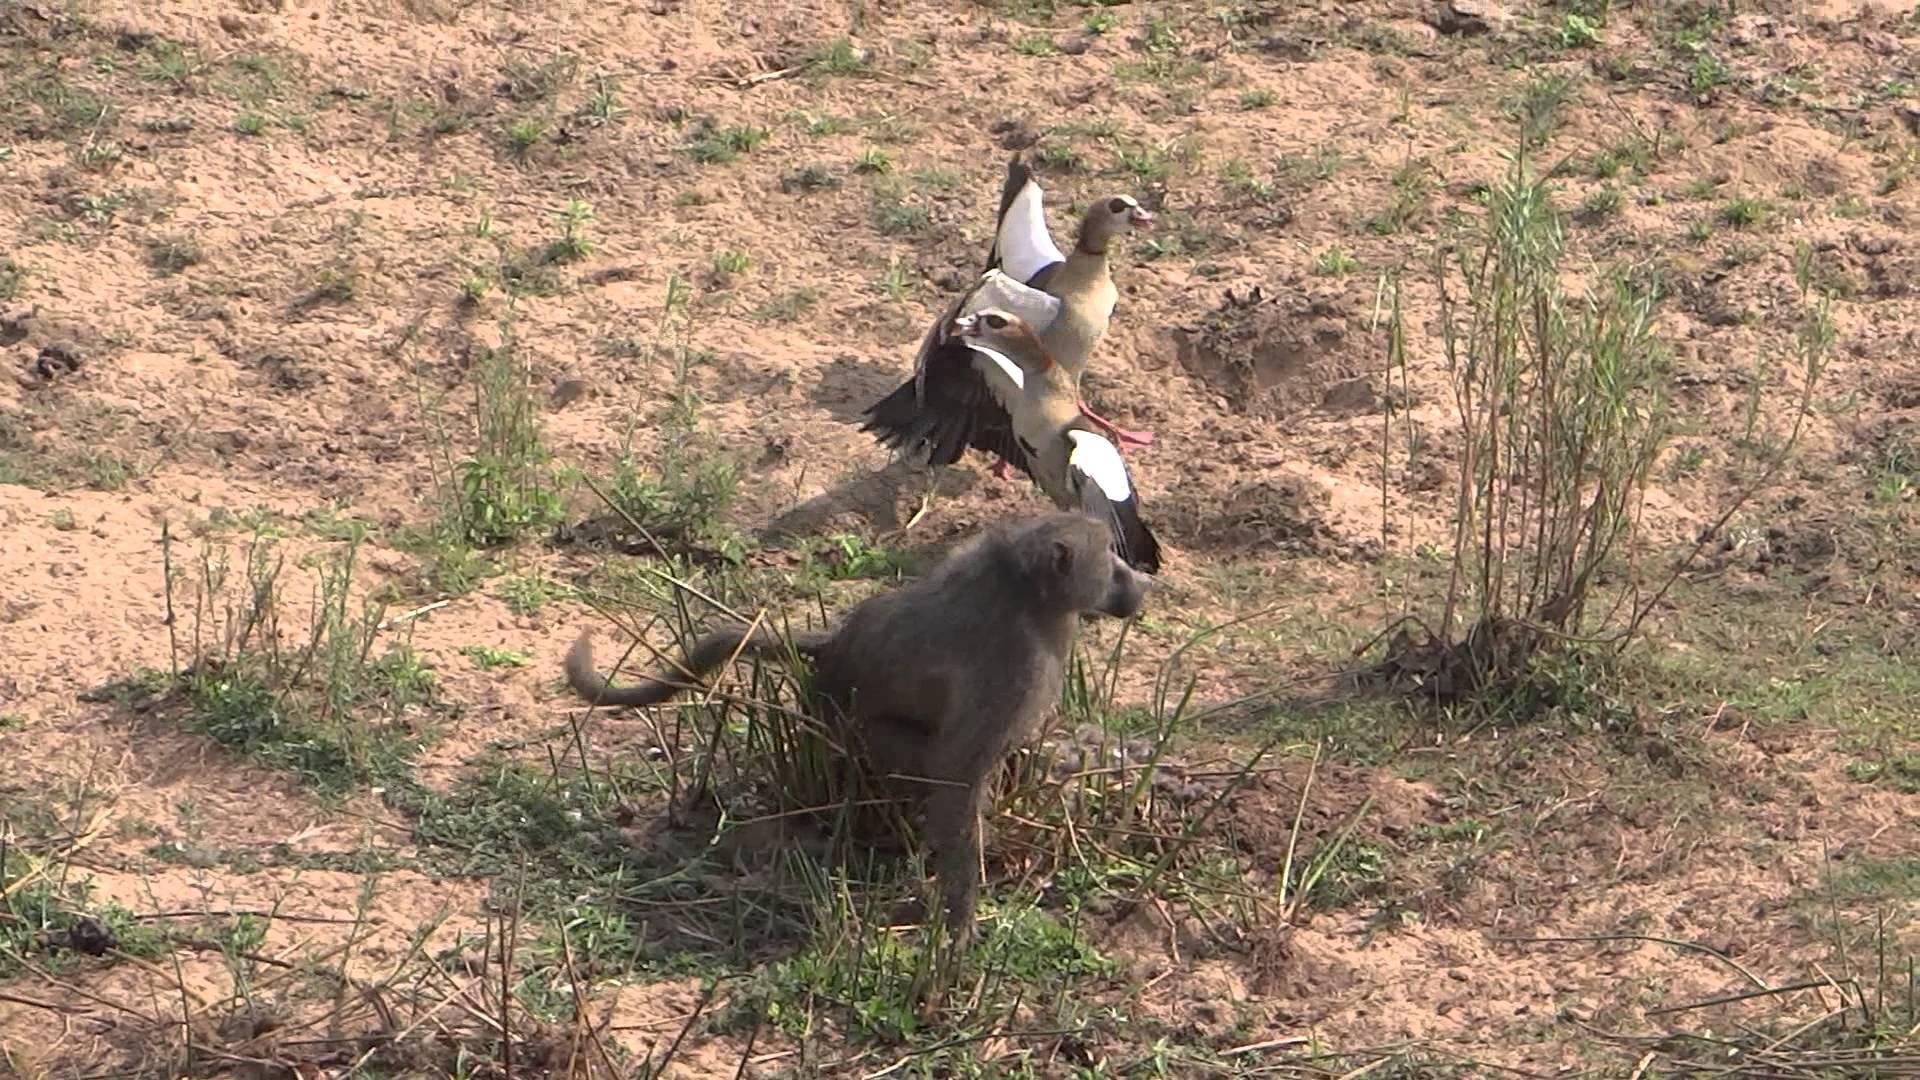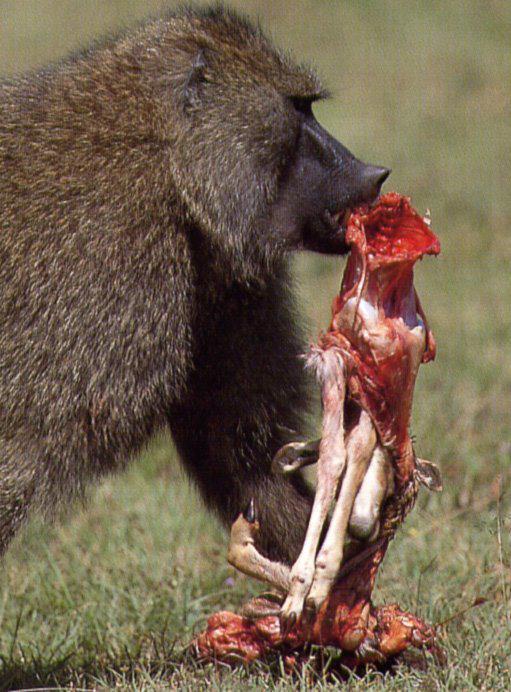The first image is the image on the left, the second image is the image on the right. Analyze the images presented: Is the assertion "There’s a single gray and white baboon with his mouth open looking forward left in the photo." valid? Answer yes or no. No. The first image is the image on the left, the second image is the image on the right. Analyze the images presented: Is the assertion "The image on the left contains exactly one animal, and the image on the right is the exact same species and gender as the image on the left." valid? Answer yes or no. No. 